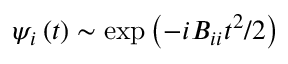Convert formula to latex. <formula><loc_0><loc_0><loc_500><loc_500>\psi _ { i } \left ( t \right ) \sim \exp { \left ( - i B _ { i i } t ^ { 2 } / 2 \right ) }</formula> 